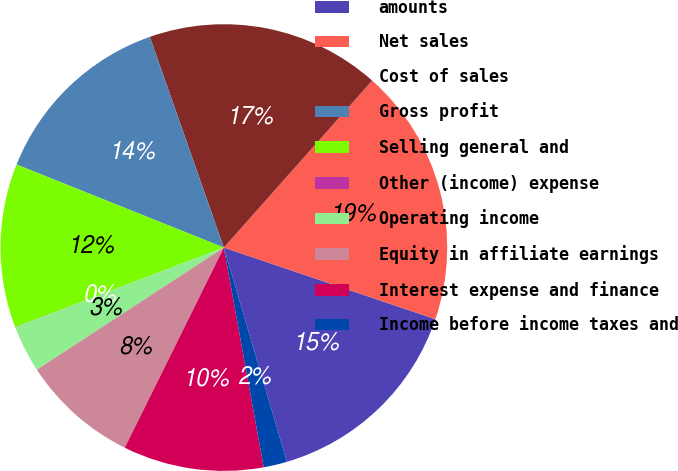<chart> <loc_0><loc_0><loc_500><loc_500><pie_chart><fcel>amounts<fcel>Net sales<fcel>Cost of sales<fcel>Gross profit<fcel>Selling general and<fcel>Other (income) expense<fcel>Operating income<fcel>Equity in affiliate earnings<fcel>Interest expense and finance<fcel>Income before income taxes and<nl><fcel>15.25%<fcel>18.64%<fcel>16.94%<fcel>13.56%<fcel>11.86%<fcel>0.01%<fcel>3.4%<fcel>8.48%<fcel>10.17%<fcel>1.7%<nl></chart> 